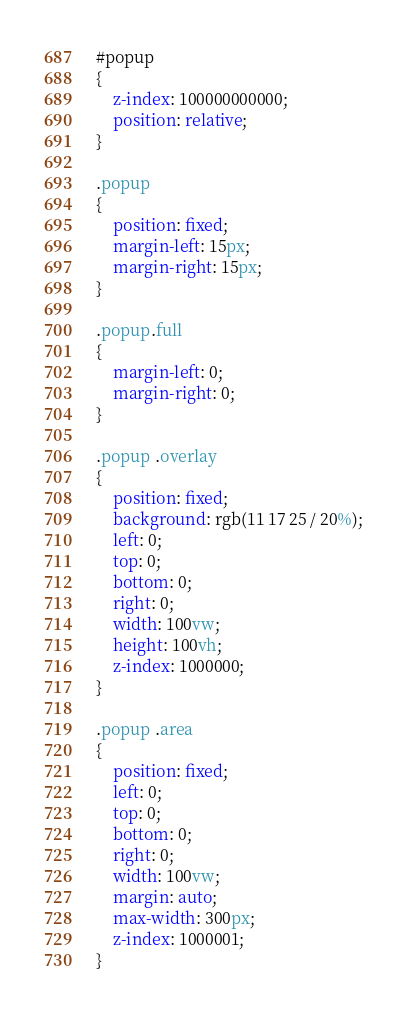Convert code to text. <code><loc_0><loc_0><loc_500><loc_500><_CSS_>#popup
{
    z-index: 100000000000;
    position: relative;
}

.popup
{
    position: fixed;
    margin-left: 15px;
    margin-right: 15px;
}

.popup.full
{
    margin-left: 0;
    margin-right: 0;
}

.popup .overlay
{
    position: fixed;
    background: rgb(11 17 25 / 20%);
    left: 0;
    top: 0;
    bottom: 0;
    right: 0;
    width: 100vw;
    height: 100vh;
    z-index: 1000000;
}

.popup .area
{
    position: fixed;
    left: 0;
    top: 0;
    bottom: 0;
    right: 0;
    width: 100vw;
    margin: auto;
    max-width: 300px;
    z-index: 1000001;
}</code> 